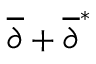Convert formula to latex. <formula><loc_0><loc_0><loc_500><loc_500>{ \overline { \partial } } + { \overline { \partial } } ^ { * }</formula> 